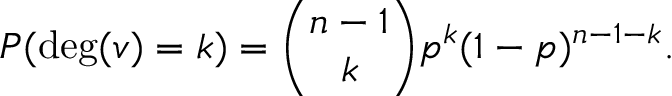Convert formula to latex. <formula><loc_0><loc_0><loc_500><loc_500>P ( \deg ( v ) = k ) = { \binom { n - 1 } { k } } p ^ { k } ( 1 - p ) ^ { n - 1 - k } .</formula> 